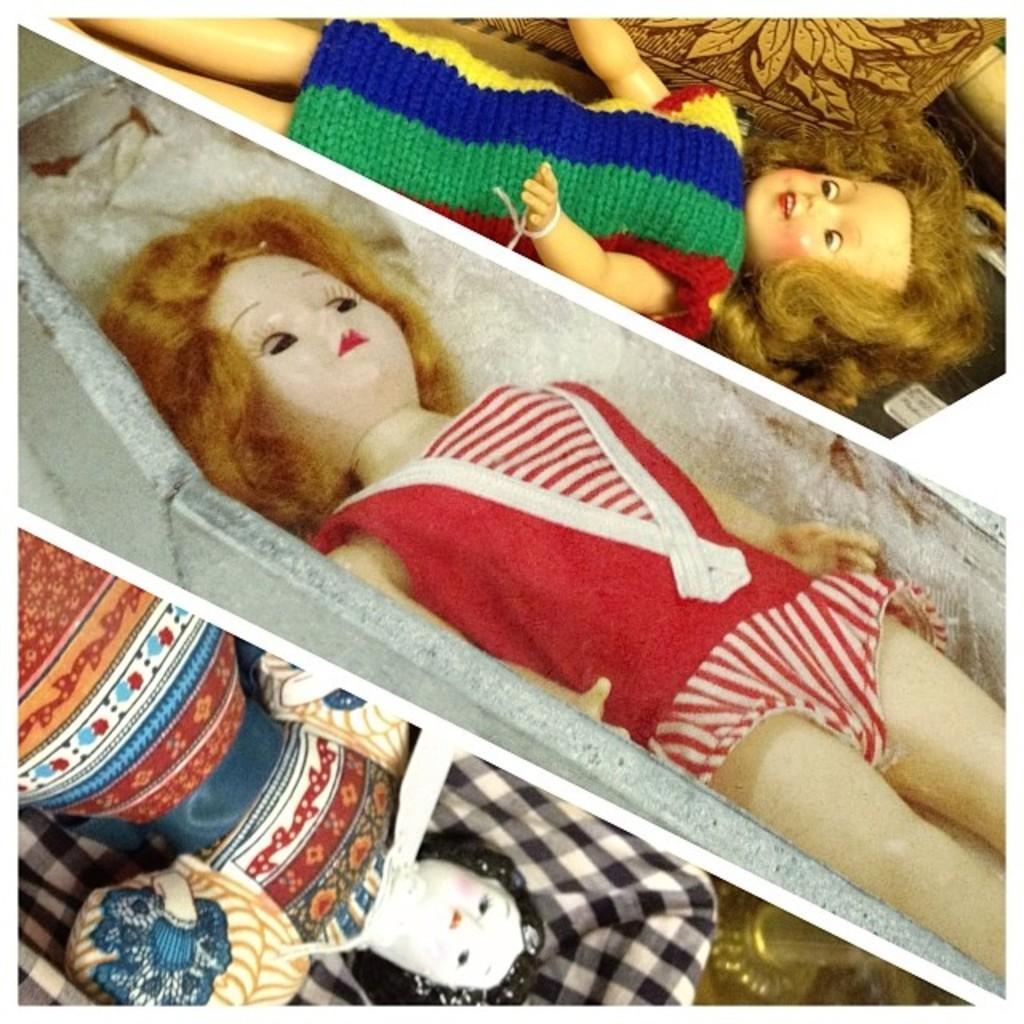Could you give a brief overview of what you see in this image? This image looks like an edited photo, in which I can see three dolls and metal objects. This image taken, maybe in a shop. 